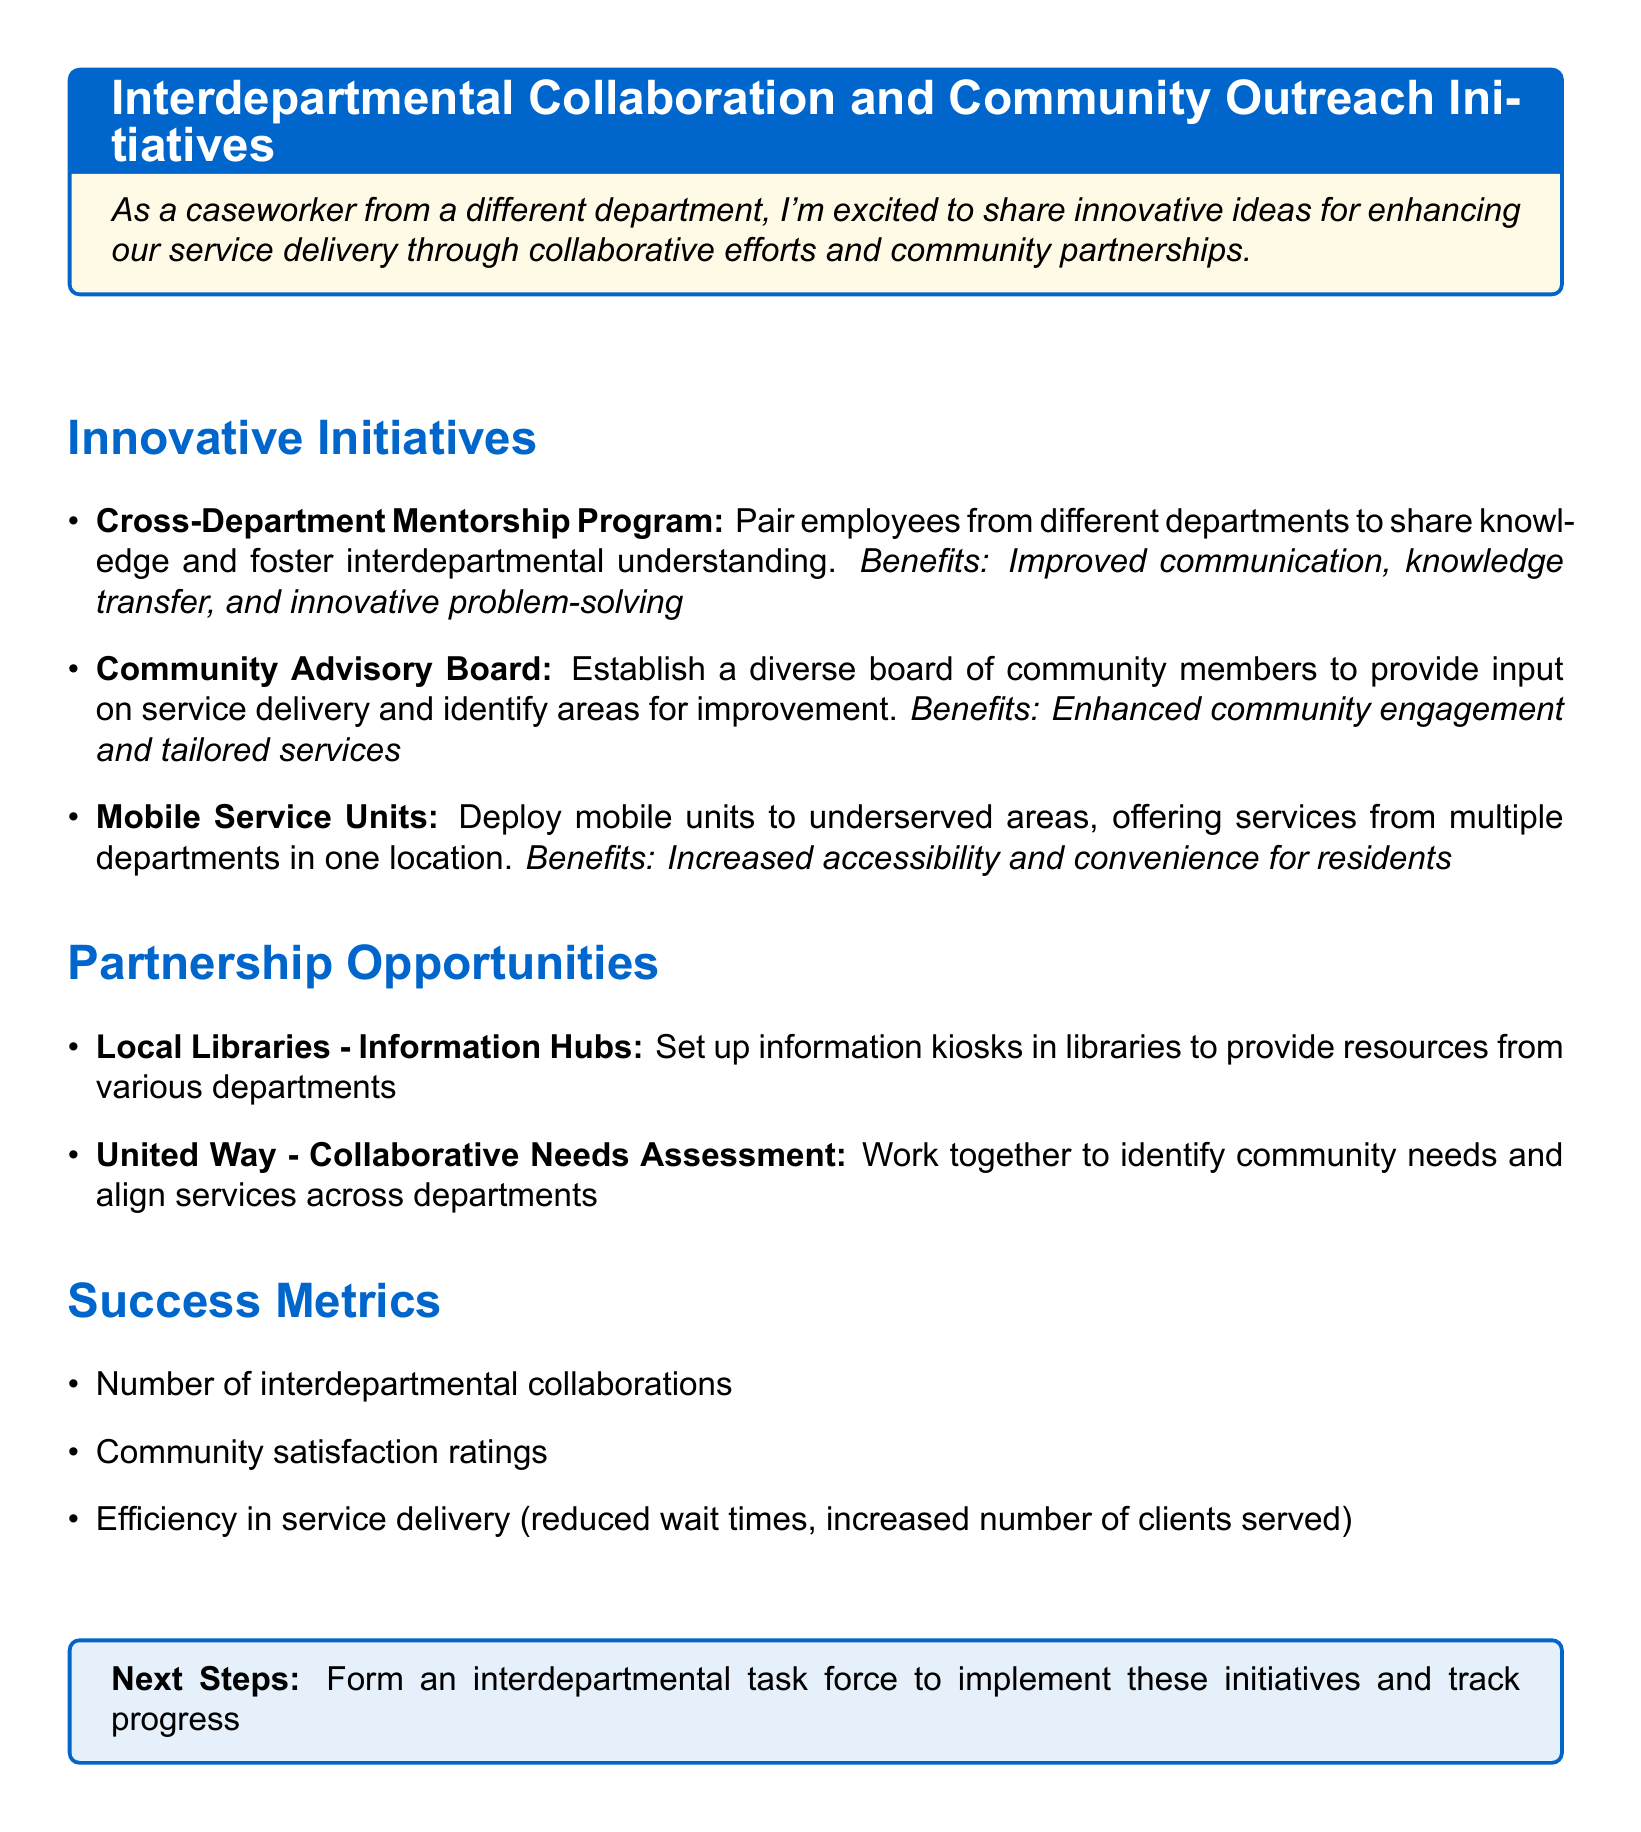What is the title of the section that discusses interdepartmental collaboration initiatives? The title is located at the top of the section about innovative initiatives, focusing on collaboration.
Answer: Innovative Initiatives How many innovative initiatives are listed in the document? The number of bullet points in the "Innovative Initiatives" section indicates how many initiatives are described.
Answer: 3 What is one benefit of the Cross-Department Mentorship Program? This benefit is mentioned directly after the initiative, outlining a positive outcome of the program.
Answer: Improved communication What type of partnership involves local libraries? This is a specific type of partnership outlined in the partnership opportunities section.
Answer: Information Hubs Which organization is mentioned for a collaborative needs assessment? The organization's name is given in the partnership opportunities section for collaboration.
Answer: United Way What is one of the success metrics listed in the document? The success metrics are stated in their section, capturing performance indicators.
Answer: Community satisfaction ratings What should be formed as the next step according to the document? The next step is indicated at the end of the document, summarizing what needs to be done next.
Answer: Interdepartmental task force What do Mobile Service Units aim to increase? This goal is directly mentioned in relation to the benefit of the Mobile Service Units.
Answer: Accessibility and convenience What color is specified as the main color in the document? The main color is defined at the beginning, used for titles and highlights.
Answer: RGB(0,102,204) 